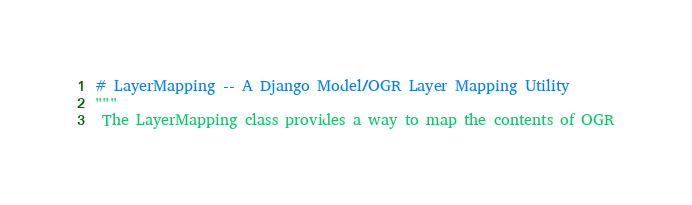<code> <loc_0><loc_0><loc_500><loc_500><_Python_># LayerMapping -- A Django Model/OGR Layer Mapping Utility
"""
 The LayerMapping class provides a way to map the contents of OGR</code> 